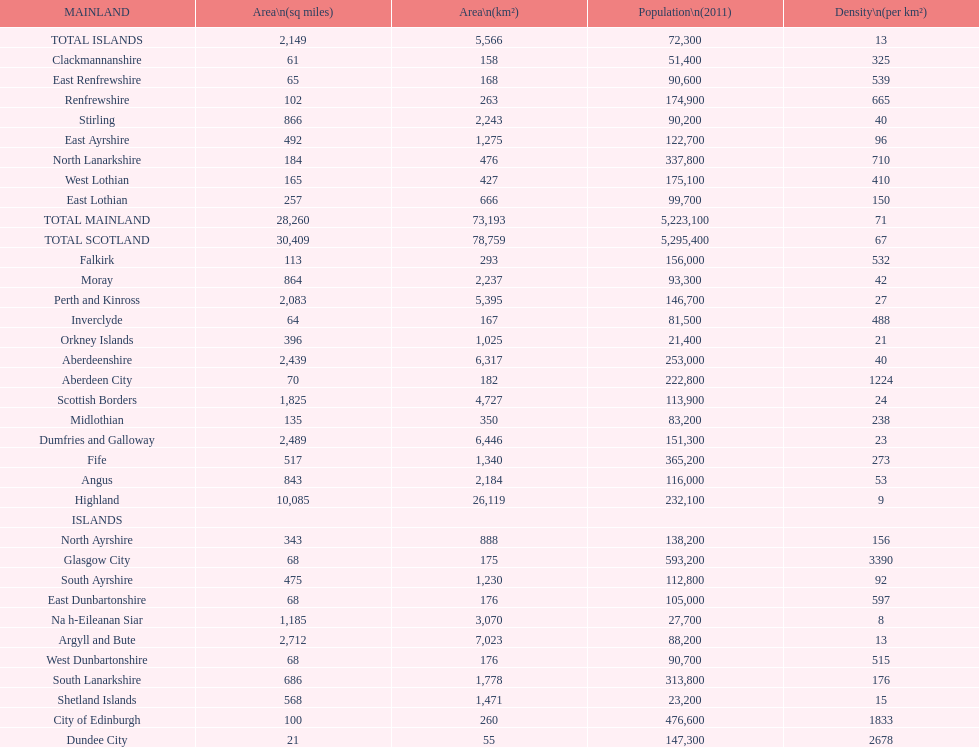What is the average population density in mainland cities? 71. Would you mind parsing the complete table? {'header': ['MAINLAND', 'Area\\n(sq miles)', 'Area\\n(km²)', 'Population\\n(2011)', 'Density\\n(per km²)'], 'rows': [['TOTAL ISLANDS', '2,149', '5,566', '72,300', '13'], ['Clackmannanshire', '61', '158', '51,400', '325'], ['East Renfrewshire', '65', '168', '90,600', '539'], ['Renfrewshire', '102', '263', '174,900', '665'], ['Stirling', '866', '2,243', '90,200', '40'], ['East Ayrshire', '492', '1,275', '122,700', '96'], ['North Lanarkshire', '184', '476', '337,800', '710'], ['West Lothian', '165', '427', '175,100', '410'], ['East Lothian', '257', '666', '99,700', '150'], ['TOTAL MAINLAND', '28,260', '73,193', '5,223,100', '71'], ['TOTAL SCOTLAND', '30,409', '78,759', '5,295,400', '67'], ['Falkirk', '113', '293', '156,000', '532'], ['Moray', '864', '2,237', '93,300', '42'], ['Perth and Kinross', '2,083', '5,395', '146,700', '27'], ['Inverclyde', '64', '167', '81,500', '488'], ['Orkney Islands', '396', '1,025', '21,400', '21'], ['Aberdeenshire', '2,439', '6,317', '253,000', '40'], ['Aberdeen City', '70', '182', '222,800', '1224'], ['Scottish Borders', '1,825', '4,727', '113,900', '24'], ['Midlothian', '135', '350', '83,200', '238'], ['Dumfries and Galloway', '2,489', '6,446', '151,300', '23'], ['Fife', '517', '1,340', '365,200', '273'], ['Angus', '843', '2,184', '116,000', '53'], ['Highland', '10,085', '26,119', '232,100', '9'], ['ISLANDS', '', '', '', ''], ['North Ayrshire', '343', '888', '138,200', '156'], ['Glasgow City', '68', '175', '593,200', '3390'], ['South Ayrshire', '475', '1,230', '112,800', '92'], ['East Dunbartonshire', '68', '176', '105,000', '597'], ['Na h-Eileanan Siar', '1,185', '3,070', '27,700', '8'], ['Argyll and Bute', '2,712', '7,023', '88,200', '13'], ['West Dunbartonshire', '68', '176', '90,700', '515'], ['South Lanarkshire', '686', '1,778', '313,800', '176'], ['Shetland Islands', '568', '1,471', '23,200', '15'], ['City of Edinburgh', '100', '260', '476,600', '1833'], ['Dundee City', '21', '55', '147,300', '2678']]} 